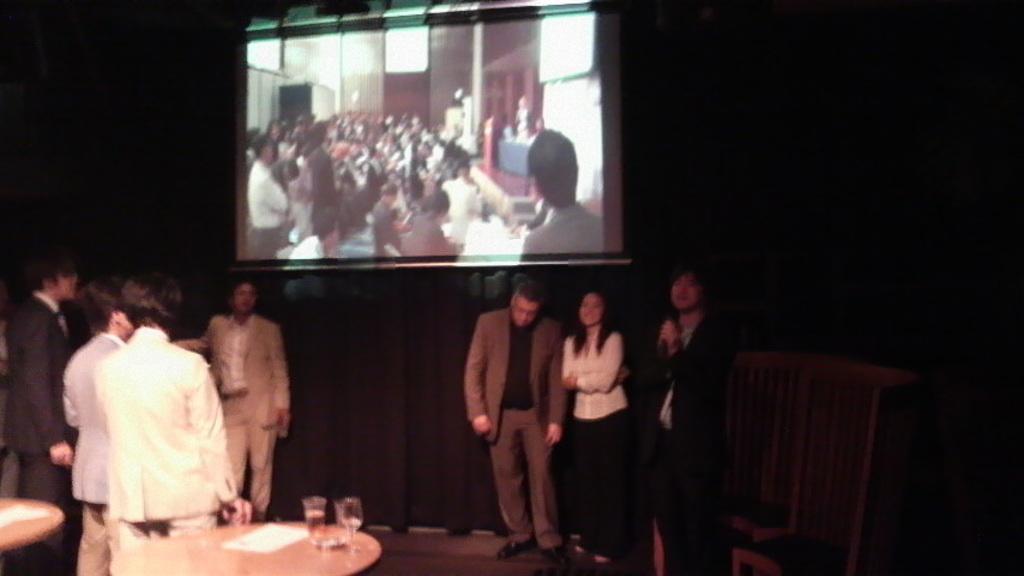Can you describe this image briefly? In this picture we can see a group of people standing on a platform, glasses and papers on tables, chairs, screen and in the background it is dark. 